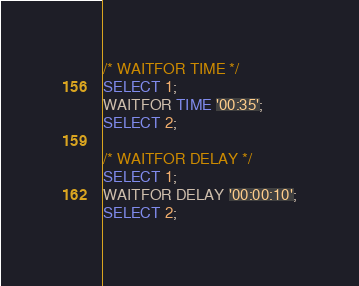Convert code to text. <code><loc_0><loc_0><loc_500><loc_500><_SQL_>/* WAITFOR TIME */
SELECT 1;
WAITFOR TIME '00:35';
SELECT 2;

/* WAITFOR DELAY */
SELECT 1;
WAITFOR DELAY '00:00:10';
SELECT 2;</code> 